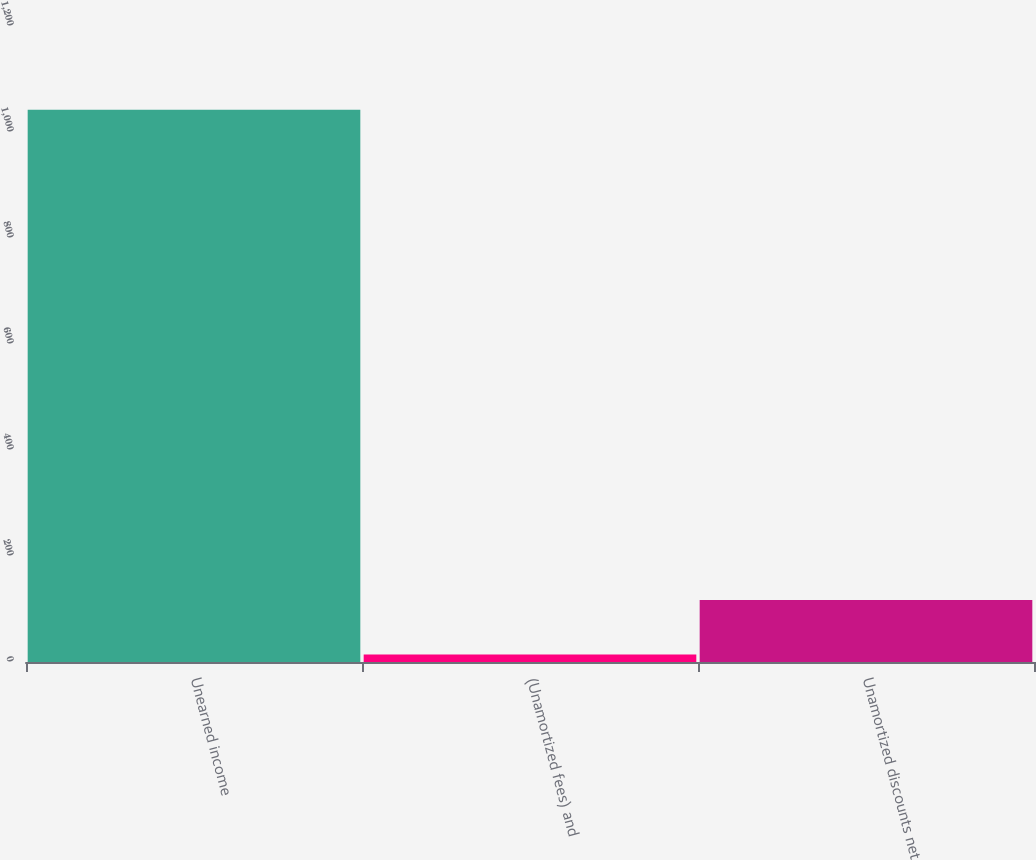Convert chart to OTSL. <chart><loc_0><loc_0><loc_500><loc_500><bar_chart><fcel>Unearned income<fcel>(Unamortized fees) and<fcel>Unamortized discounts net<nl><fcel>1042<fcel>14<fcel>116.8<nl></chart> 